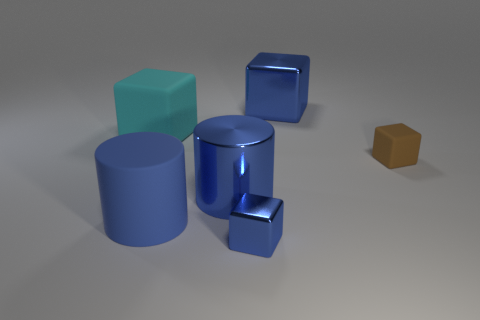Subtract 1 cubes. How many cubes are left? 3 Subtract all green cubes. Subtract all blue balls. How many cubes are left? 4 Add 3 small green spheres. How many objects exist? 9 Subtract all blocks. How many objects are left? 2 Add 5 tiny brown matte blocks. How many tiny brown matte blocks are left? 6 Add 4 big blue rubber things. How many big blue rubber things exist? 5 Subtract 1 blue cylinders. How many objects are left? 5 Subtract all shiny blocks. Subtract all big rubber blocks. How many objects are left? 3 